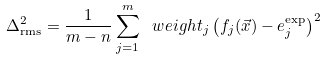Convert formula to latex. <formula><loc_0><loc_0><loc_500><loc_500>\Delta _ { \text {rms} } ^ { 2 } = \frac { 1 } { m - n } \sum _ { j = 1 } ^ { m } \ w e i g h t _ { j } \left ( f _ { j } ( { \vec { x } } ) - e _ { j } ^ { \text {exp} } \right ) ^ { 2 }</formula> 